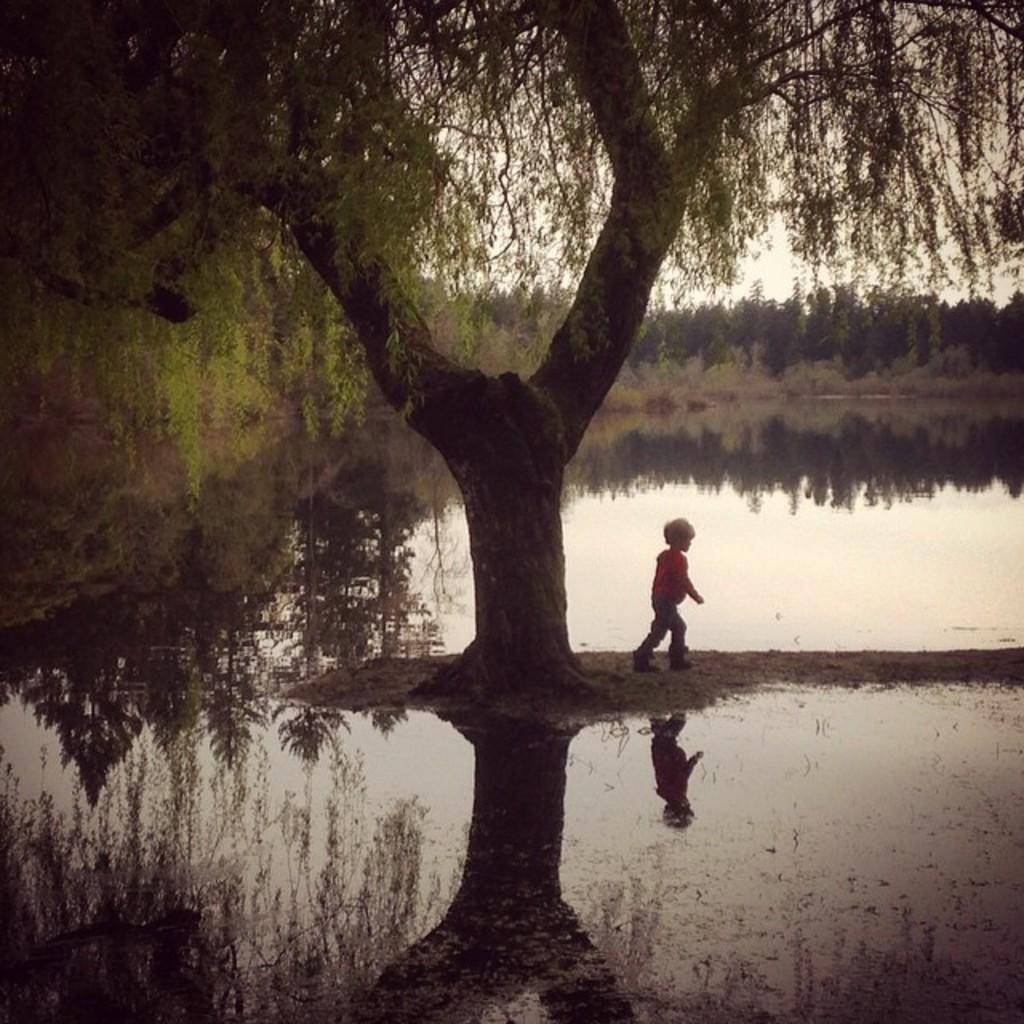What is the kid in the image doing? The kid is walking on the ground in the image. What natural feature can be seen in the background of the image? There is a lake in the image. What type of vegetation is present in the image? There are trees and bushes in the image. What part of the natural environment is visible in the image? The sky is visible in the image. What team is the kid supporting in the image? There is no indication of a team or any sports activity in the image. What is the kid's reaction to the disgusting smell in the image? There is no mention of a smell, let alone a disgusting one, in the image. 